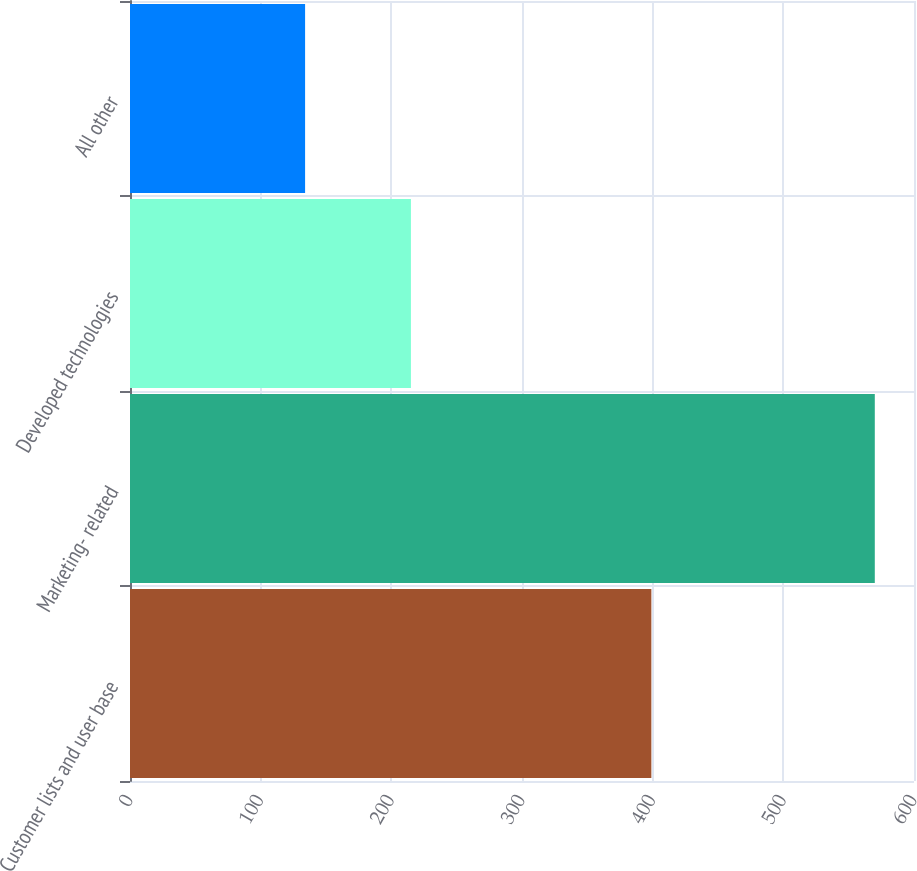<chart> <loc_0><loc_0><loc_500><loc_500><bar_chart><fcel>Customer lists and user base<fcel>Marketing- related<fcel>Developed technologies<fcel>All other<nl><fcel>399<fcel>570<fcel>215<fcel>134<nl></chart> 